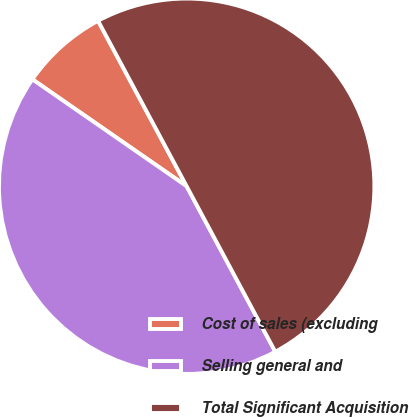Convert chart. <chart><loc_0><loc_0><loc_500><loc_500><pie_chart><fcel>Cost of sales (excluding<fcel>Selling general and<fcel>Total Significant Acquisition<nl><fcel>7.53%<fcel>42.47%<fcel>50.0%<nl></chart> 